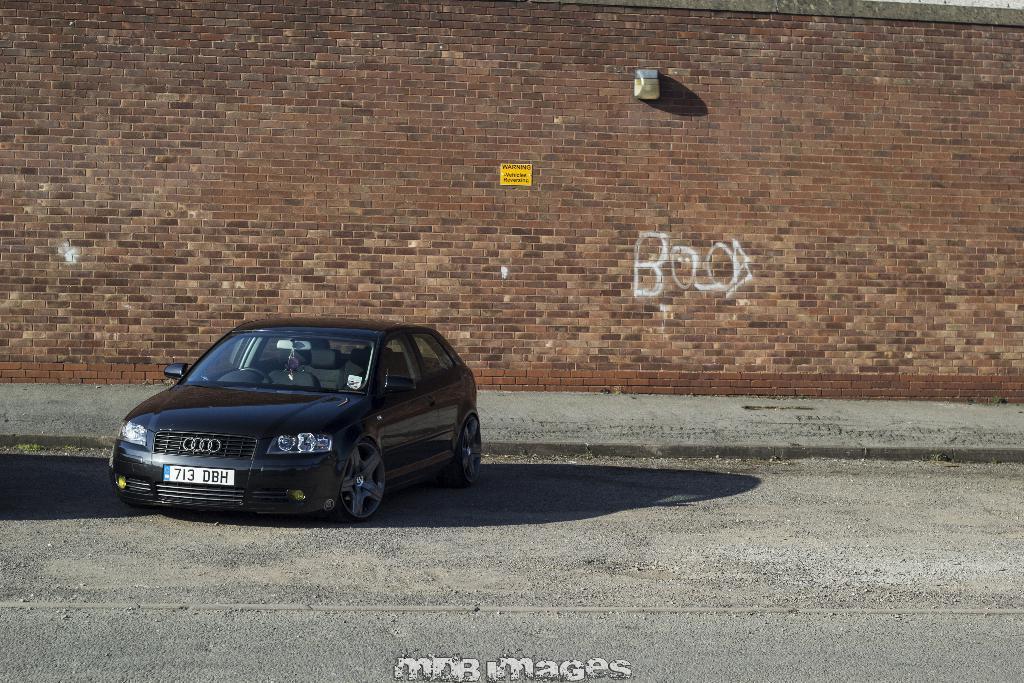Could you give a brief overview of what you see in this image? In this image I can see a car on the ground. In the background there is a wall. A the bottom of this image I can see some edited text. 